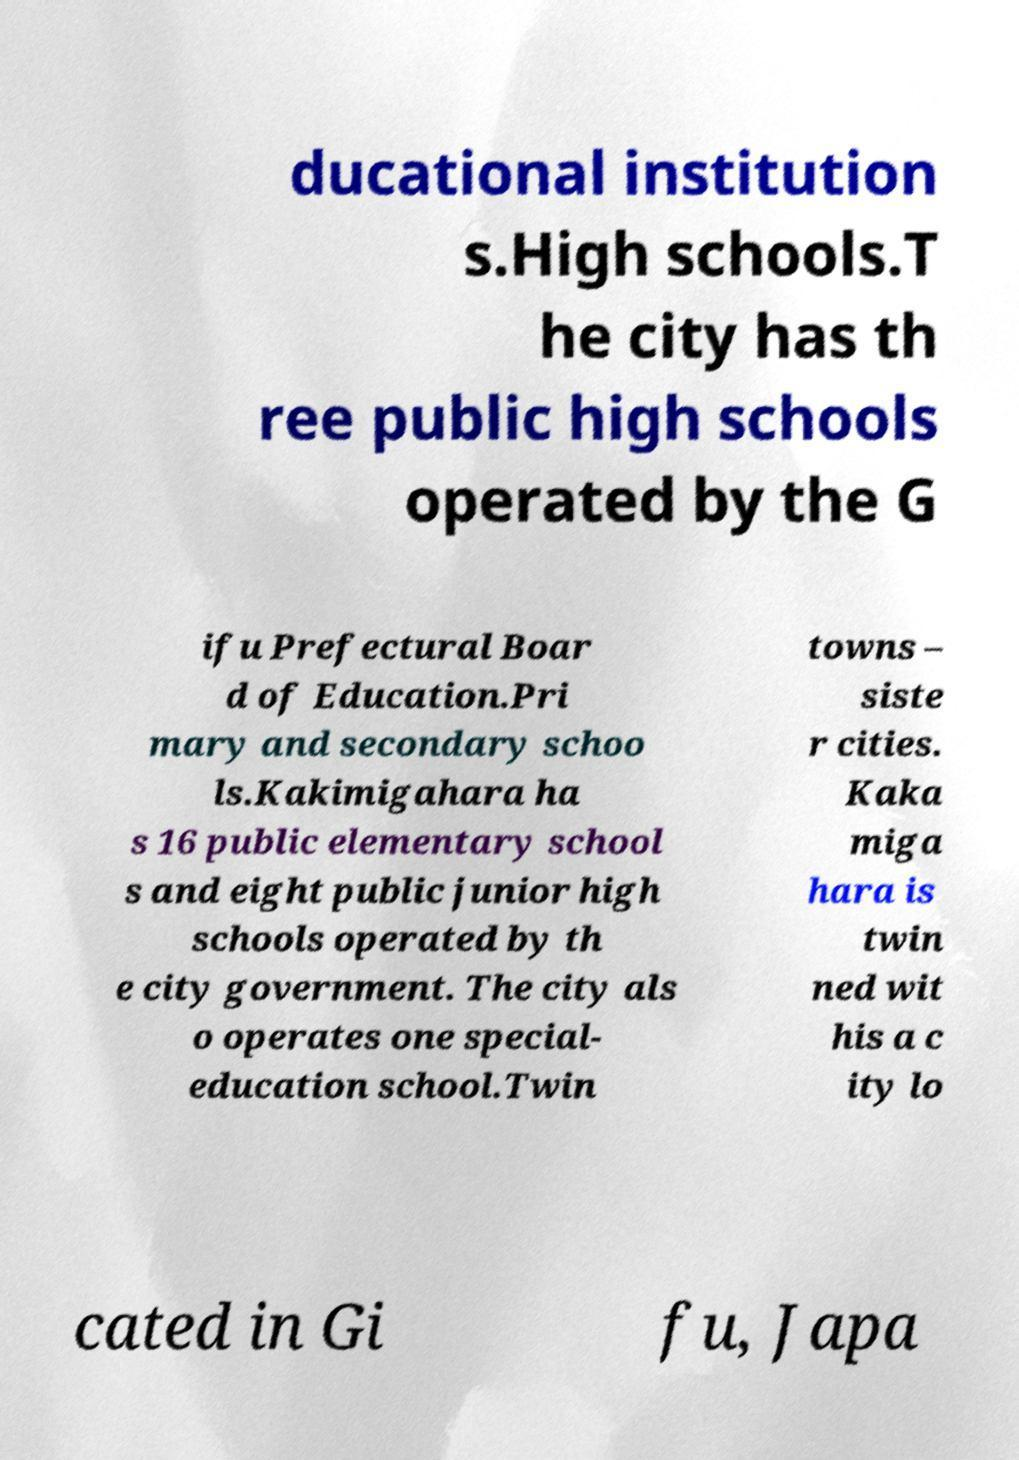For documentation purposes, I need the text within this image transcribed. Could you provide that? ducational institution s.High schools.T he city has th ree public high schools operated by the G ifu Prefectural Boar d of Education.Pri mary and secondary schoo ls.Kakimigahara ha s 16 public elementary school s and eight public junior high schools operated by th e city government. The city als o operates one special- education school.Twin towns – siste r cities. Kaka miga hara is twin ned wit his a c ity lo cated in Gi fu, Japa 